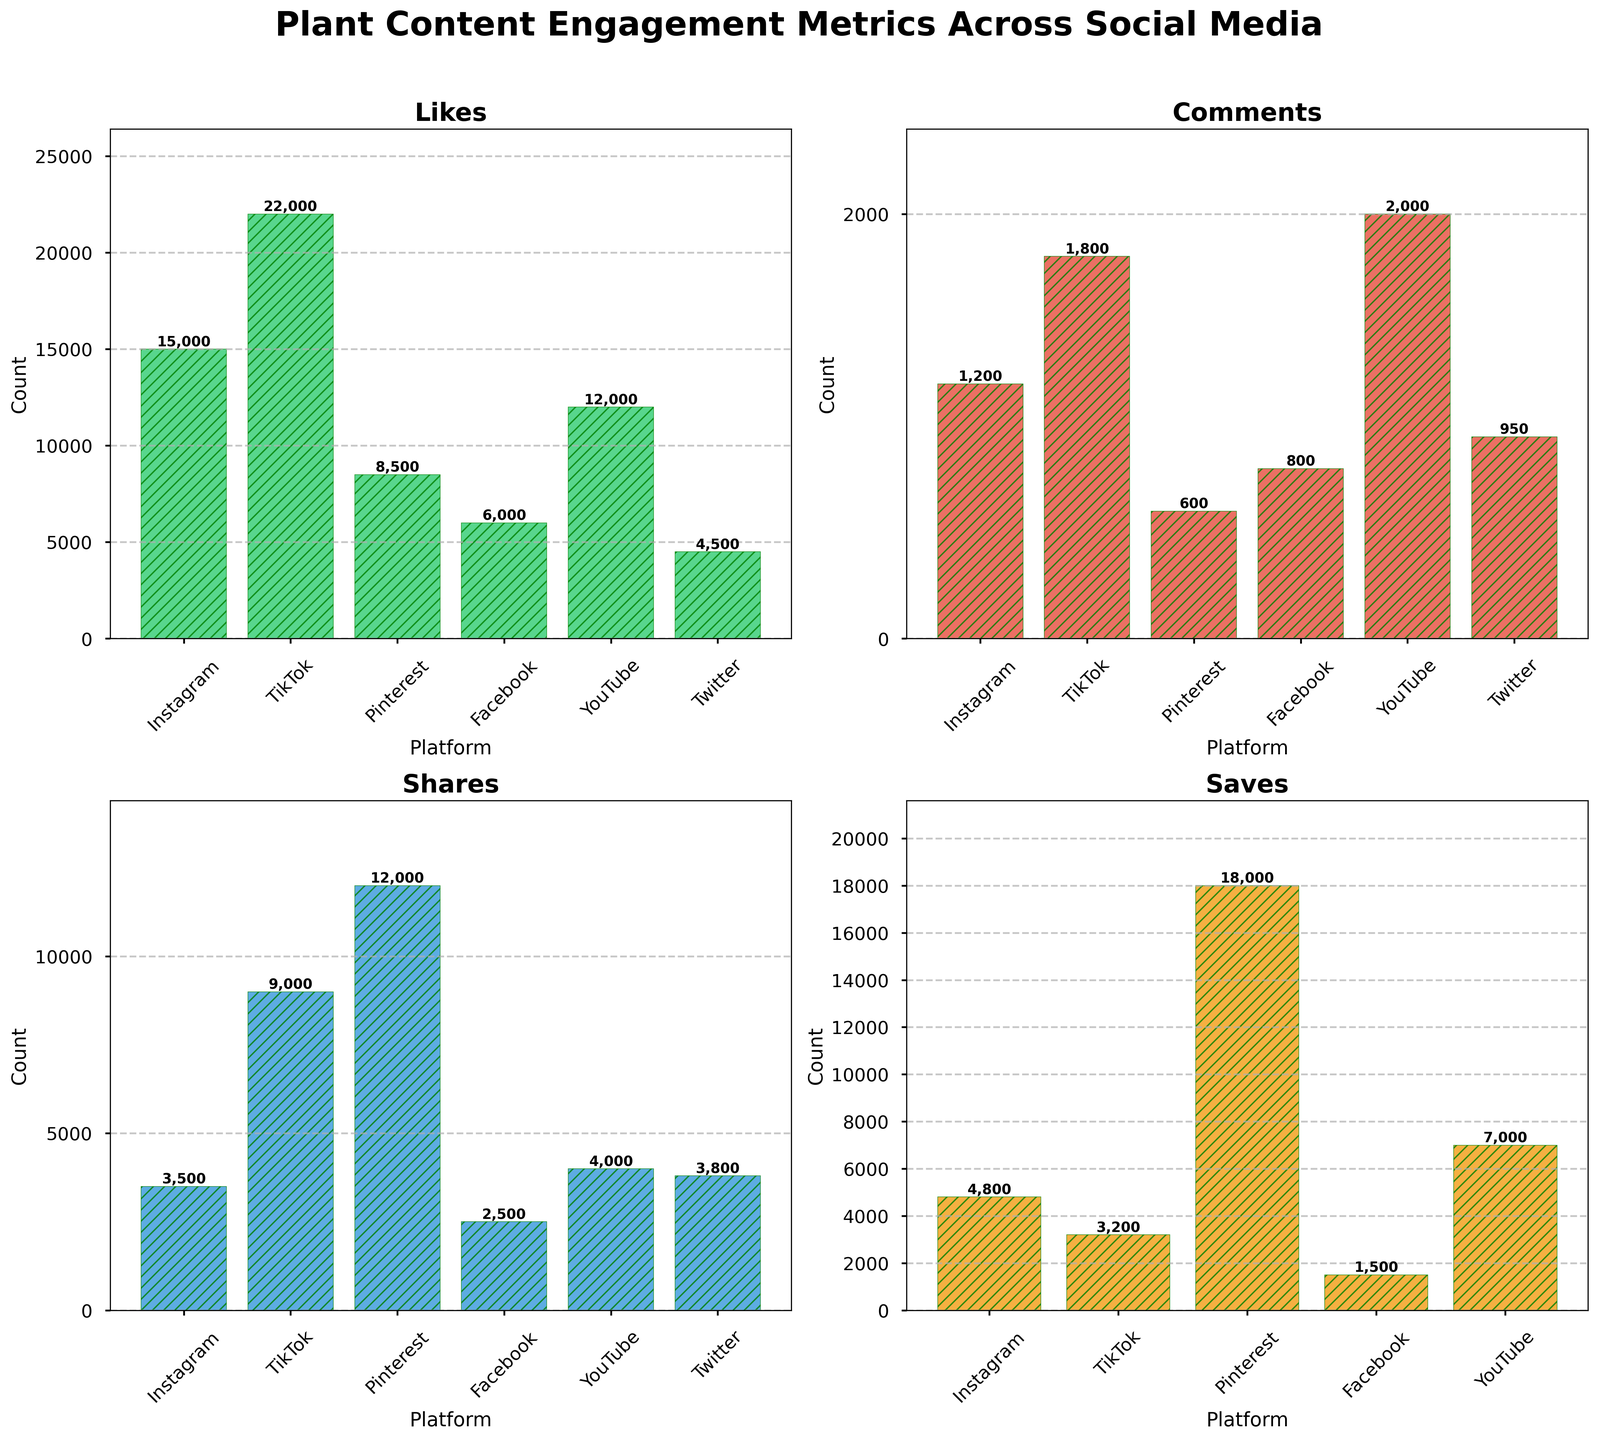What is the title of the overall figure? The title of the overall figure is usually placed at the top and is prominently displayed in the largest font size. Based on the figure description, the title is "Plant Content Engagement Metrics Across Social Media".
Answer: Plant Content Engagement Metrics Across Social Media Which platform received the highest number of likes? Looking at the "Likes" subplot, the bar for TikTok is the tallest, indicating that it has the highest number of likes.
Answer: TikTok What are the four metrics displayed in the subplots? The metrics displayed in the subplots can be found in the titles of each subplot. The titles are succinctly listed in the problem: Likes, Comments, Shares, Saves.
Answer: Likes, Comments, Shares, Saves Which platform received the least number of comments? In the "Comments" subplot, the bar for Pinterest is the shortest, indicating that it received the least number of comments.
Answer: Pinterest What is the combined number of shares on Instagram and TikTok? To find the combined number of shares, add the shares for Instagram (3500) and TikTok (9000). So, 3500 + 9000 = 12500 shares.
Answer: 12500 How many platforms are shown in each subplot? Count the number of bars (or platform names) in any one of the subplots. There are six platforms: Instagram, TikTok, Pinterest, Facebook, YouTube, and Twitter.
Answer: Six Which two platforms have the highest number of saves? In the "Saves" subplot, the bars for Pinterest and YouTube are the tallest, indicating the highest number of saves for these two platforms.
Answer: Pinterest and YouTube How does the number of saves on Pinterest compare to the number of shares on Facebook? Compare the heights of the bars for Pinterest in the "Saves" subplot and Facebook in the "Shares" subplot. Pinterest has 18000 saves, whereas Facebook has 2500 shares. 18000 is significantly larger than 2500.
Answer: Pinterest has significantly more saves than Facebook has shares Which platform has more shares: Instagram or Twitter? Compare the heights of the bars for Instagram and Twitter in the "Shares" subplot. Instagram has 3500 shares, while Twitter has 3800 shares. Therefore, Twitter has slightly more shares.
Answer: Twitter Which metric has the smallest maximum value across all platforms? Compare the maximum values in each of the subplots. The subplot with the shortest tallest bar will have the smallest maximum value. 'Comments' appear to have the smallest maximum value, with YouTube at 2000 comments.
Answer: Comments 